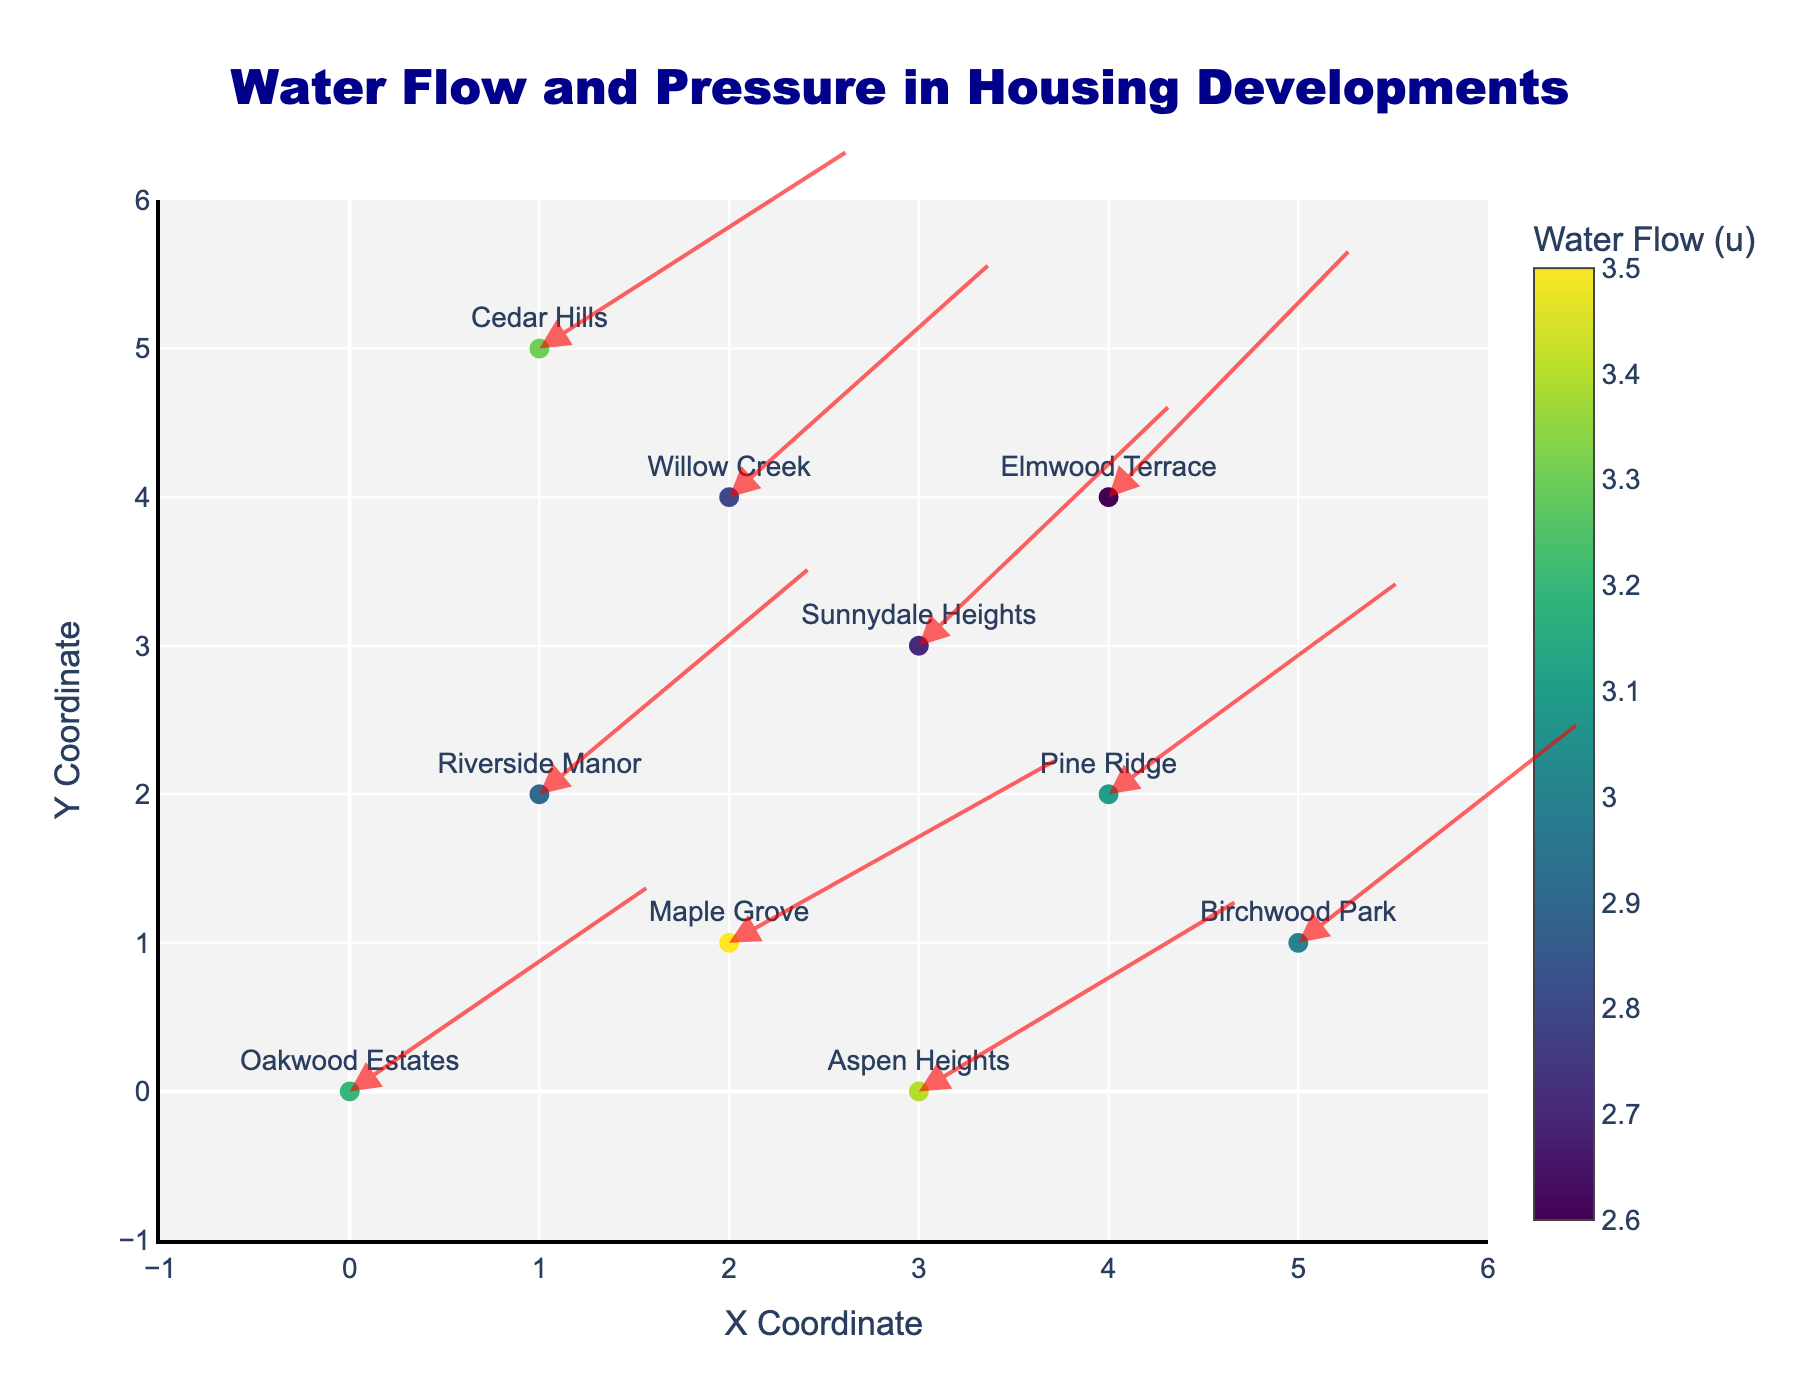What's the title of the plot? The title is centrally placed at the top of the plot and clearly states the focus.
Answer: Water Flow and Pressure in Housing Developments How many housing developments are shown in the plot? Each development can be identified by its label near the data points, which total to 10 different developments.
Answer: 10 Which development has the highest water flow? By observing the color shade and the value in the color bar, the lighter the color, the higher the water flow. Aspen Heights has a water flow of 3.4, which is the highest.
Answer: Aspen Heights What are the x and y coordinates for Oakwood Estates? Oakwood Estates label is near the data point with coordinates (0,0).
Answer: (0, 0) What's the approximate range of x and y coordinates covered in the plot? By looking at the axes range, the plot covers from -1 to 6 on both x and y axes.
Answer: -1 to 6 What is the average value of the water flow for all visible developments? Sum all 'u' values and divide by the number of developments: (3.2 + 2.9 + 3.5 + 2.7 + 3.1 + 2.8 + 3.3 + 3.0 + 2.6 + 3.4) / 10 = 3.05
Answer: 3.05 Which development has the greatest angle from horizontal to its flow vector? The angle can be approximated by visually interpreting the steepest arrow direction. Sunnydale Heights has a high vertical component, indicating a greater angle.
Answer: Sunnydale Heights Which two developments appear to have the most similar flow directions? Comparing the orientations of the arrows, Pine Ridge and Cedar Hills arrows are pointing in similar directions.
Answer: Pine Ridge and Cedar Hills How does the water flow direction in Cedar Hills compare to Willow Creek? The arrows indicate the direction of flow; Cedar Hills arrow points more horizontally while Willow Creek's arrow points more vertically.
Answer: Cedar Hills is more horizontal, Willow Creek more vertical 